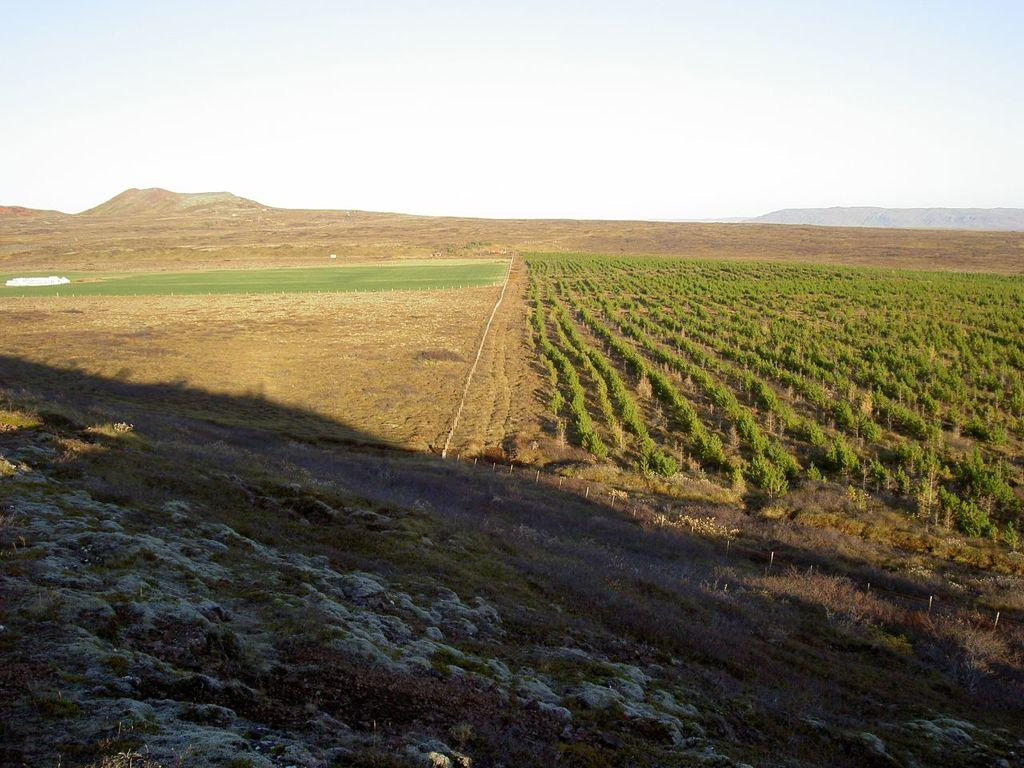What type of landscape is depicted in the image? The image features fields. What can be found growing in the fields? There are plants in the fields. What can be seen in the distance behind the fields? There are hills in the background of the image. What is visible above the fields and hills? The sky is visible in the background of the image. What type of steel is used to construct the grip on the plants in the image? There is no steel or grip present on the plants in the image; they are natural plants growing in the fields. 